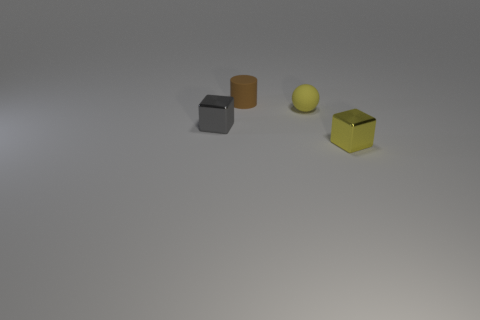Add 3 brown things. How many objects exist? 7 Subtract all balls. How many objects are left? 3 Subtract 0 brown blocks. How many objects are left? 4 Subtract all green matte blocks. Subtract all small gray shiny blocks. How many objects are left? 3 Add 2 tiny matte cylinders. How many tiny matte cylinders are left? 3 Add 1 small yellow rubber objects. How many small yellow rubber objects exist? 2 